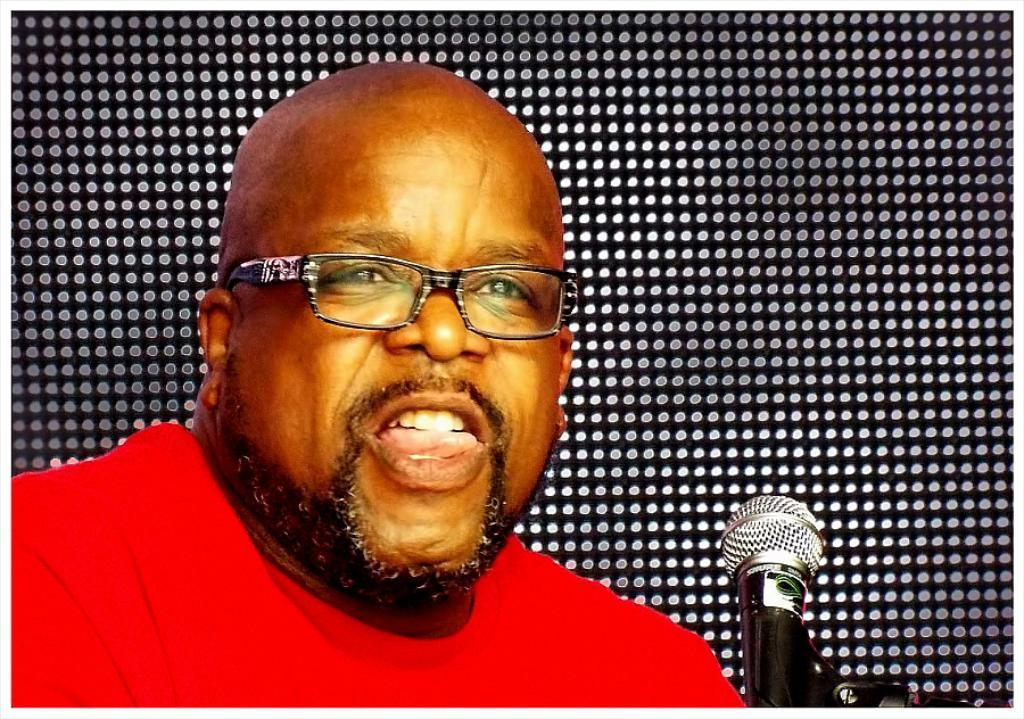Who or what is the main subject in the image? There is a person in the image. What can be observed about the person's appearance? The person is wearing spectacles. What object is present in the image that might be used for amplifying sound? There is a microphone in the image. Can you describe the background of the image? The background of the image is black with white dots. What type of road can be seen in the image? There is no road present in the image. What magical spell is the person casting in the image? There is no indication of magic or a spell being cast in the image. 